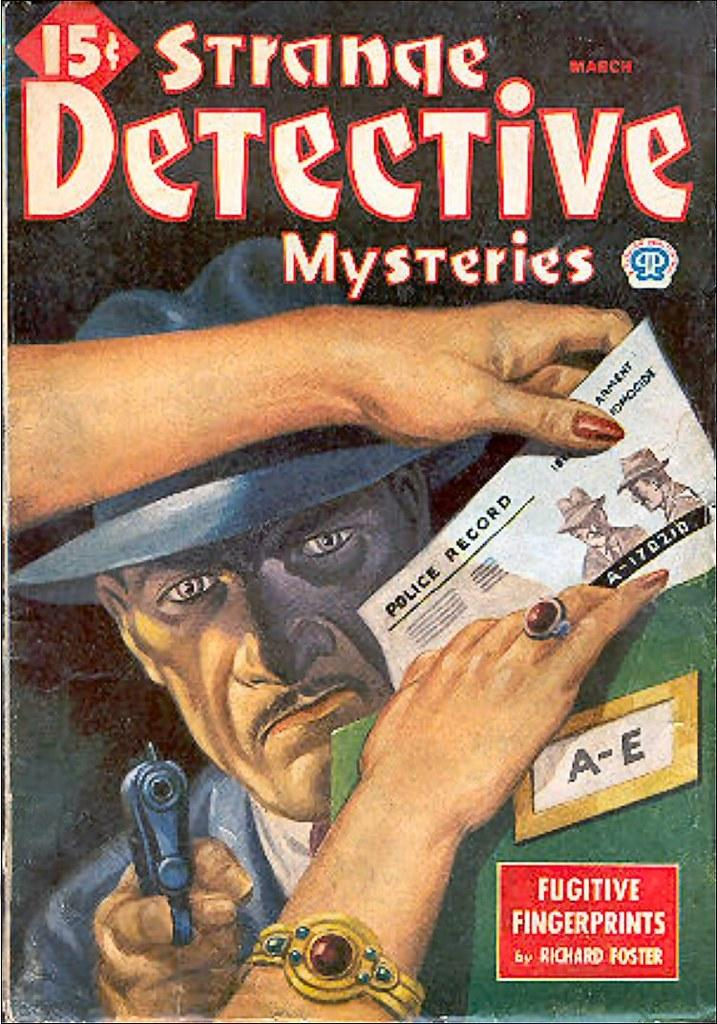Provide a one-sentence caption for the provided image. A comic book cover of the Strange Detective Mysteries. 